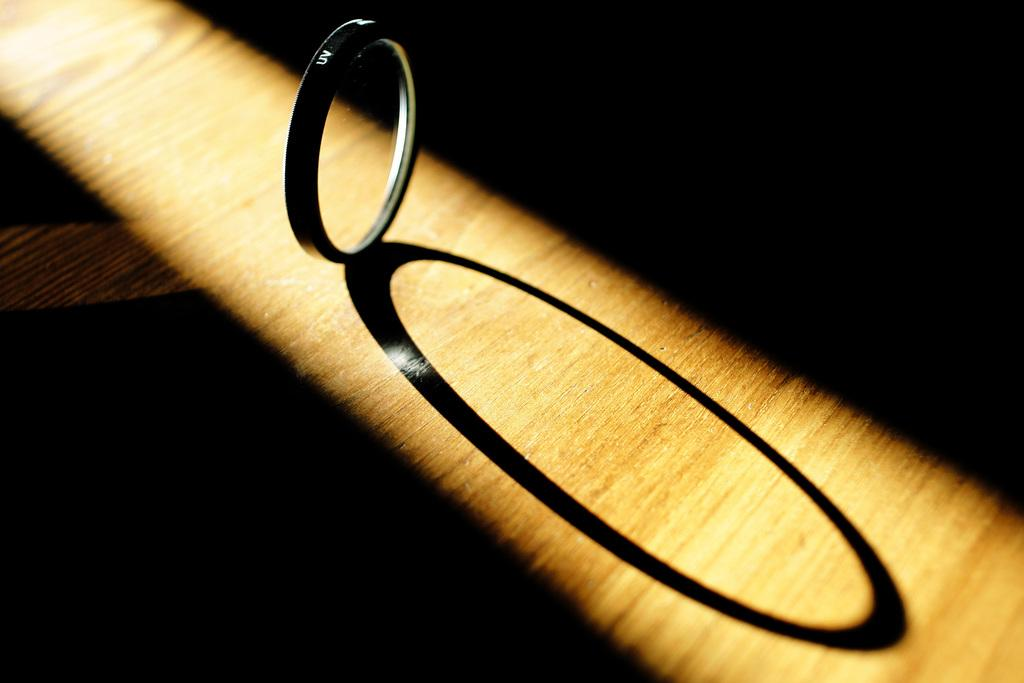What object is on the table in the image? There is a ring on a table in the image. Can you describe any additional features related to the ring? There is a shadow of the ring visible in the image. What type of wound can be seen on the robin in the image? There is no robin present in the image, and therefore no wound can be observed. 